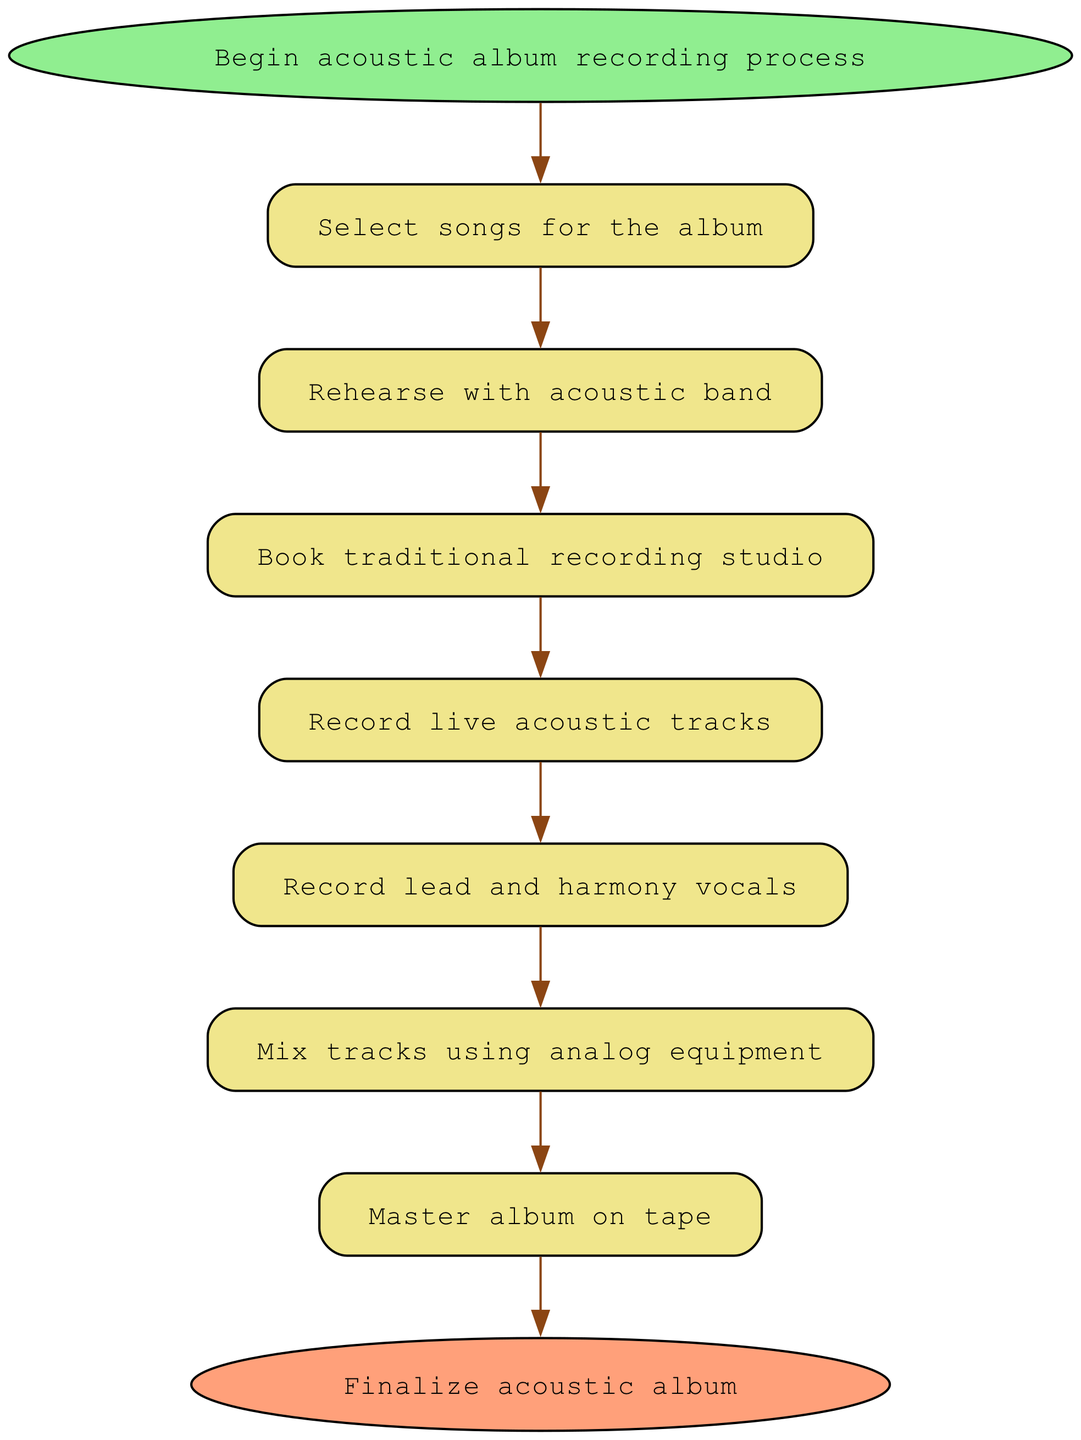What's the first step in the workflow? The workflow starts with the "Begin acoustic album recording process" node, which is the entry point of the diagram.
Answer: Begin acoustic album recording process How many nodes are there in the diagram? By counting all the nodes listed in the workflow, there are a total of 9 nodes that represent different steps in the recording process.
Answer: 9 What is the last step in the workflow? The final step is represented by the "Finalize acoustic album" node, which indicates the end of the recording process.
Answer: Finalize acoustic album Which step comes after recording live acoustic tracks? The step that follows "Record live acoustic tracks" is "Record lead and harmony vocals," indicating the sequence of actions in the workflow.
Answer: Record lead and harmony vocals What type of recording equipment is mentioned in the mixing step? The mixing step refers to "analog equipment," specifying the type of equipment used for mixing the tracks.
Answer: Analog equipment How many edges connect the nodes in the diagram? The diagram has 8 edges that indicate the direct connections or transitions between the various steps in the workflow.
Answer: 8 What two nodes are connected directly by an edge? The "Rehearse with acoustic band" node is connected directly to the "Book traditional recording studio" node; this shows the flow from rehearsing to booking the studio.
Answer: Rehearse with acoustic band and Book traditional recording studio Which node indicates the need for studio bookings? The "Book traditional recording studio" node indicates that a studio needs to be booked after the rehearsal stage in the workflow.
Answer: Book traditional recording studio What is the purpose of the mastering step? The purpose of the "Master album on tape" step is to finalize the audio quality, ensuring it meets industry standards before distribution.
Answer: Master album on tape 